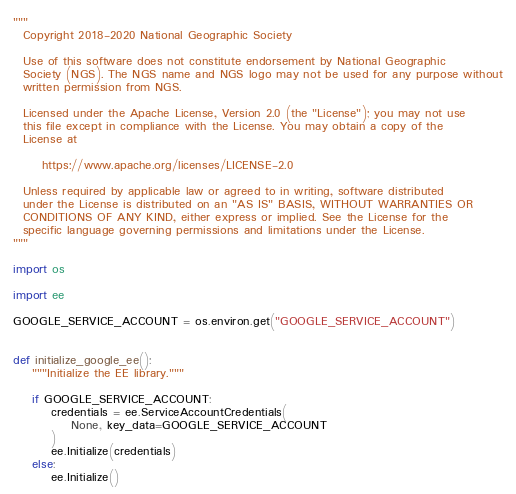<code> <loc_0><loc_0><loc_500><loc_500><_Python_>"""
  Copyright 2018-2020 National Geographic Society

  Use of this software does not constitute endorsement by National Geographic
  Society (NGS). The NGS name and NGS logo may not be used for any purpose without
  written permission from NGS.

  Licensed under the Apache License, Version 2.0 (the "License"); you may not use
  this file except in compliance with the License. You may obtain a copy of the
  License at

      https://www.apache.org/licenses/LICENSE-2.0

  Unless required by applicable law or agreed to in writing, software distributed
  under the License is distributed on an "AS IS" BASIS, WITHOUT WARRANTIES OR
  CONDITIONS OF ANY KIND, either express or implied. See the License for the
  specific language governing permissions and limitations under the License.
"""

import os

import ee

GOOGLE_SERVICE_ACCOUNT = os.environ.get("GOOGLE_SERVICE_ACCOUNT")


def initialize_google_ee():
    """Initialize the EE library."""

    if GOOGLE_SERVICE_ACCOUNT:
        credentials = ee.ServiceAccountCredentials(
            None, key_data=GOOGLE_SERVICE_ACCOUNT
        )
        ee.Initialize(credentials)
    else:
        ee.Initialize()

</code> 